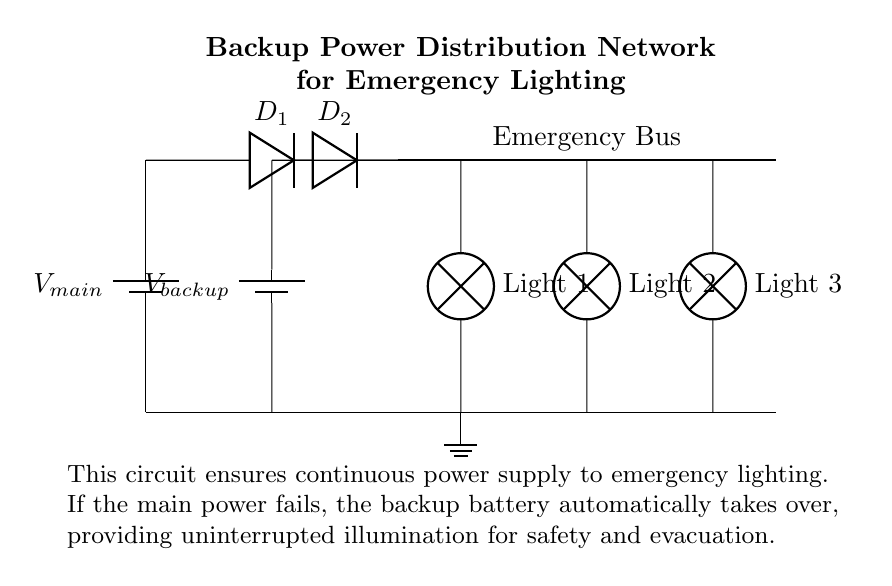What type of circuit is represented? The circuit is a backup power distribution network, designed for emergency lighting. This type of circuit ensures that in a power outage, an alternative power source maintains the light functionality.
Answer: Backup power distribution network How many lamps are connected to the emergency bus? The circuit diagram shows three lamps connected to the emergency bus. Each lamp represents a point in the circuit where emergency lighting is provided when the main power is unavailable.
Answer: Three What is the purpose of the diodes in the circuit? The diodes are used to allow current to flow in only one direction, ensuring that either the main power or backup power can charge the emergency bus but not both simultaneously. This prevents a backfeed that could damage the power sources.
Answer: Current direction control What happens if the main power supply fails? When the main power supply fails, the backup battery automatically takes over supplying power to the emergency lights without any manual intervention. This is achieved through the configuration of the diodes which allows the backup source to energize the bus.
Answer: Backup battery takes over What voltage is supplied by the backup battery? The circuit diagram indicates the backup battery, denoted as V backup, but does not specify a numerical voltage. Typically, this voltage would be designed to match the operational requirements of the emergency lights as indicated by the circuit standards.
Answer: V backup What does the ground connection signify in this circuit? The ground connection in this circuit is essential for safety, providing a reference point for the voltage levels in the circuit, and serving as a safety path for fault currents. This ensures that in the case of a malfunction, the electrical system remains safe.
Answer: Safety reference 